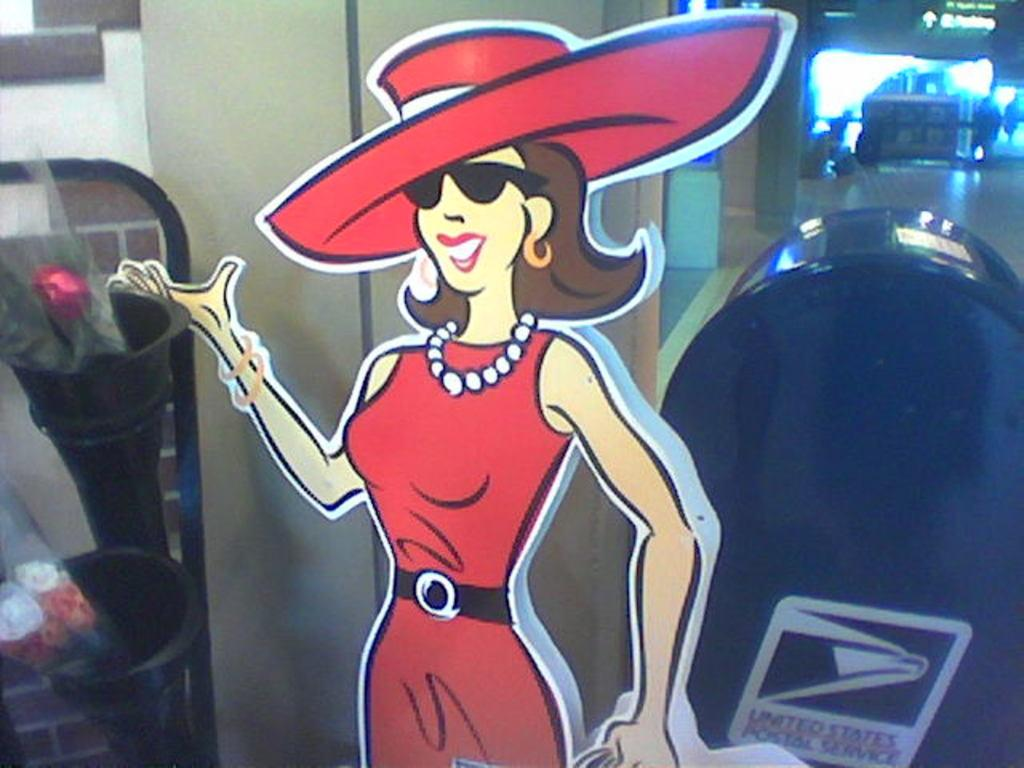<image>
Present a compact description of the photo's key features. A cardboard stand up of a woman in red is next to a United States Postal Service mail box. 